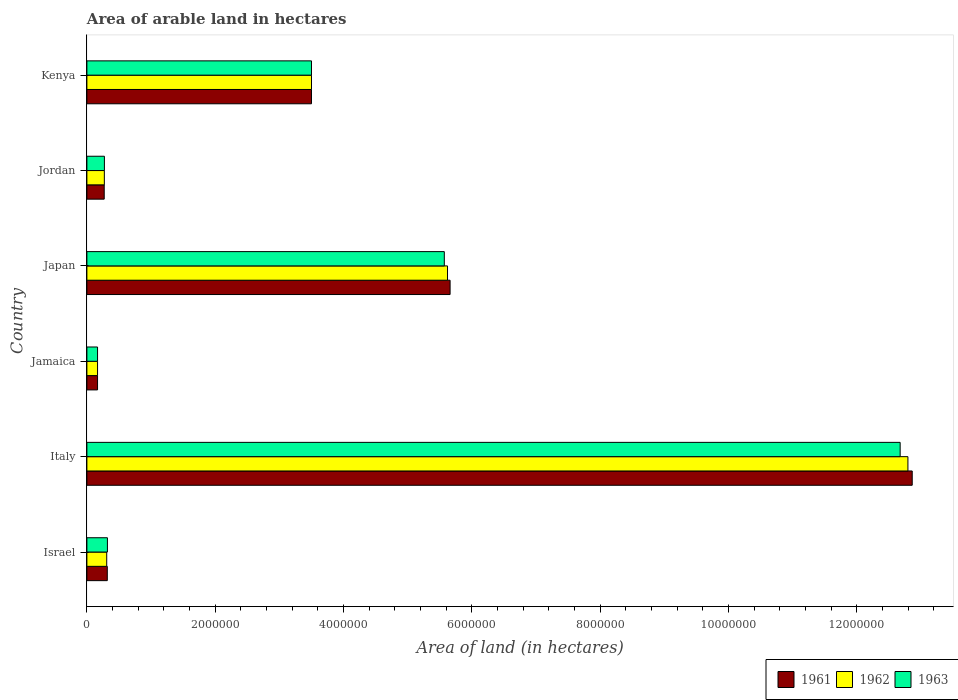How many groups of bars are there?
Make the answer very short. 6. What is the label of the 1st group of bars from the top?
Give a very brief answer. Kenya. In how many cases, is the number of bars for a given country not equal to the number of legend labels?
Keep it short and to the point. 0. What is the total arable land in 1961 in Japan?
Offer a terse response. 5.66e+06. Across all countries, what is the maximum total arable land in 1963?
Keep it short and to the point. 1.27e+07. Across all countries, what is the minimum total arable land in 1961?
Ensure brevity in your answer.  1.66e+05. In which country was the total arable land in 1963 minimum?
Your answer should be very brief. Jamaica. What is the total total arable land in 1963 in the graph?
Your response must be concise. 2.25e+07. What is the difference between the total arable land in 1963 in Israel and that in Italy?
Provide a succinct answer. -1.24e+07. What is the difference between the total arable land in 1962 in Israel and the total arable land in 1963 in Jamaica?
Provide a succinct answer. 1.43e+05. What is the average total arable land in 1963 per country?
Ensure brevity in your answer.  3.75e+06. In how many countries, is the total arable land in 1963 greater than 8000000 hectares?
Provide a succinct answer. 1. What is the ratio of the total arable land in 1961 in Israel to that in Jordan?
Your answer should be compact. 1.18. What is the difference between the highest and the second highest total arable land in 1961?
Provide a short and direct response. 7.20e+06. What is the difference between the highest and the lowest total arable land in 1963?
Provide a succinct answer. 1.25e+07. In how many countries, is the total arable land in 1962 greater than the average total arable land in 1962 taken over all countries?
Your answer should be compact. 2. Is the sum of the total arable land in 1963 in Italy and Jordan greater than the maximum total arable land in 1961 across all countries?
Offer a very short reply. Yes. How many bars are there?
Your response must be concise. 18. Are all the bars in the graph horizontal?
Your response must be concise. Yes. How many countries are there in the graph?
Your answer should be very brief. 6. Does the graph contain any zero values?
Offer a very short reply. No. How many legend labels are there?
Provide a succinct answer. 3. What is the title of the graph?
Ensure brevity in your answer.  Area of arable land in hectares. Does "1981" appear as one of the legend labels in the graph?
Your response must be concise. No. What is the label or title of the X-axis?
Offer a terse response. Area of land (in hectares). What is the label or title of the Y-axis?
Make the answer very short. Country. What is the Area of land (in hectares) of 1961 in Israel?
Provide a succinct answer. 3.18e+05. What is the Area of land (in hectares) of 1962 in Israel?
Your answer should be very brief. 3.09e+05. What is the Area of land (in hectares) of 1963 in Israel?
Give a very brief answer. 3.20e+05. What is the Area of land (in hectares) of 1961 in Italy?
Your answer should be very brief. 1.29e+07. What is the Area of land (in hectares) in 1962 in Italy?
Your answer should be very brief. 1.28e+07. What is the Area of land (in hectares) of 1963 in Italy?
Provide a short and direct response. 1.27e+07. What is the Area of land (in hectares) in 1961 in Jamaica?
Ensure brevity in your answer.  1.66e+05. What is the Area of land (in hectares) in 1962 in Jamaica?
Offer a very short reply. 1.66e+05. What is the Area of land (in hectares) in 1963 in Jamaica?
Keep it short and to the point. 1.66e+05. What is the Area of land (in hectares) of 1961 in Japan?
Keep it short and to the point. 5.66e+06. What is the Area of land (in hectares) in 1962 in Japan?
Your response must be concise. 5.62e+06. What is the Area of land (in hectares) of 1963 in Japan?
Offer a terse response. 5.57e+06. What is the Area of land (in hectares) in 1961 in Jordan?
Give a very brief answer. 2.70e+05. What is the Area of land (in hectares) in 1962 in Jordan?
Your answer should be compact. 2.72e+05. What is the Area of land (in hectares) in 1963 in Jordan?
Keep it short and to the point. 2.73e+05. What is the Area of land (in hectares) of 1961 in Kenya?
Keep it short and to the point. 3.50e+06. What is the Area of land (in hectares) of 1962 in Kenya?
Ensure brevity in your answer.  3.50e+06. What is the Area of land (in hectares) in 1963 in Kenya?
Provide a short and direct response. 3.50e+06. Across all countries, what is the maximum Area of land (in hectares) of 1961?
Your answer should be compact. 1.29e+07. Across all countries, what is the maximum Area of land (in hectares) in 1962?
Give a very brief answer. 1.28e+07. Across all countries, what is the maximum Area of land (in hectares) of 1963?
Give a very brief answer. 1.27e+07. Across all countries, what is the minimum Area of land (in hectares) in 1961?
Ensure brevity in your answer.  1.66e+05. Across all countries, what is the minimum Area of land (in hectares) in 1962?
Give a very brief answer. 1.66e+05. Across all countries, what is the minimum Area of land (in hectares) in 1963?
Your response must be concise. 1.66e+05. What is the total Area of land (in hectares) in 1961 in the graph?
Provide a succinct answer. 2.28e+07. What is the total Area of land (in hectares) in 1962 in the graph?
Provide a short and direct response. 2.27e+07. What is the total Area of land (in hectares) of 1963 in the graph?
Your answer should be very brief. 2.25e+07. What is the difference between the Area of land (in hectares) of 1961 in Israel and that in Italy?
Make the answer very short. -1.25e+07. What is the difference between the Area of land (in hectares) of 1962 in Israel and that in Italy?
Your answer should be compact. -1.25e+07. What is the difference between the Area of land (in hectares) in 1963 in Israel and that in Italy?
Provide a short and direct response. -1.24e+07. What is the difference between the Area of land (in hectares) in 1961 in Israel and that in Jamaica?
Keep it short and to the point. 1.52e+05. What is the difference between the Area of land (in hectares) of 1962 in Israel and that in Jamaica?
Make the answer very short. 1.43e+05. What is the difference between the Area of land (in hectares) of 1963 in Israel and that in Jamaica?
Provide a succinct answer. 1.54e+05. What is the difference between the Area of land (in hectares) of 1961 in Israel and that in Japan?
Keep it short and to the point. -5.34e+06. What is the difference between the Area of land (in hectares) in 1962 in Israel and that in Japan?
Keep it short and to the point. -5.31e+06. What is the difference between the Area of land (in hectares) of 1963 in Israel and that in Japan?
Give a very brief answer. -5.25e+06. What is the difference between the Area of land (in hectares) in 1961 in Israel and that in Jordan?
Your answer should be compact. 4.80e+04. What is the difference between the Area of land (in hectares) in 1962 in Israel and that in Jordan?
Your answer should be compact. 3.70e+04. What is the difference between the Area of land (in hectares) in 1963 in Israel and that in Jordan?
Your answer should be compact. 4.70e+04. What is the difference between the Area of land (in hectares) of 1961 in Israel and that in Kenya?
Provide a succinct answer. -3.18e+06. What is the difference between the Area of land (in hectares) in 1962 in Israel and that in Kenya?
Make the answer very short. -3.19e+06. What is the difference between the Area of land (in hectares) of 1963 in Israel and that in Kenya?
Make the answer very short. -3.18e+06. What is the difference between the Area of land (in hectares) in 1961 in Italy and that in Jamaica?
Your response must be concise. 1.27e+07. What is the difference between the Area of land (in hectares) in 1962 in Italy and that in Jamaica?
Offer a very short reply. 1.26e+07. What is the difference between the Area of land (in hectares) in 1963 in Italy and that in Jamaica?
Offer a very short reply. 1.25e+07. What is the difference between the Area of land (in hectares) of 1961 in Italy and that in Japan?
Keep it short and to the point. 7.20e+06. What is the difference between the Area of land (in hectares) of 1962 in Italy and that in Japan?
Your response must be concise. 7.18e+06. What is the difference between the Area of land (in hectares) in 1963 in Italy and that in Japan?
Your response must be concise. 7.10e+06. What is the difference between the Area of land (in hectares) of 1961 in Italy and that in Jordan?
Provide a succinct answer. 1.26e+07. What is the difference between the Area of land (in hectares) in 1962 in Italy and that in Jordan?
Offer a terse response. 1.25e+07. What is the difference between the Area of land (in hectares) of 1963 in Italy and that in Jordan?
Give a very brief answer. 1.24e+07. What is the difference between the Area of land (in hectares) in 1961 in Italy and that in Kenya?
Your answer should be very brief. 9.36e+06. What is the difference between the Area of land (in hectares) in 1962 in Italy and that in Kenya?
Provide a short and direct response. 9.30e+06. What is the difference between the Area of land (in hectares) of 1963 in Italy and that in Kenya?
Make the answer very short. 9.17e+06. What is the difference between the Area of land (in hectares) in 1961 in Jamaica and that in Japan?
Offer a very short reply. -5.49e+06. What is the difference between the Area of land (in hectares) of 1962 in Jamaica and that in Japan?
Your response must be concise. -5.45e+06. What is the difference between the Area of land (in hectares) in 1963 in Jamaica and that in Japan?
Your answer should be compact. -5.40e+06. What is the difference between the Area of land (in hectares) in 1961 in Jamaica and that in Jordan?
Your answer should be very brief. -1.04e+05. What is the difference between the Area of land (in hectares) of 1962 in Jamaica and that in Jordan?
Give a very brief answer. -1.06e+05. What is the difference between the Area of land (in hectares) in 1963 in Jamaica and that in Jordan?
Provide a succinct answer. -1.07e+05. What is the difference between the Area of land (in hectares) in 1961 in Jamaica and that in Kenya?
Offer a terse response. -3.33e+06. What is the difference between the Area of land (in hectares) of 1962 in Jamaica and that in Kenya?
Your response must be concise. -3.33e+06. What is the difference between the Area of land (in hectares) in 1963 in Jamaica and that in Kenya?
Provide a short and direct response. -3.33e+06. What is the difference between the Area of land (in hectares) in 1961 in Japan and that in Jordan?
Keep it short and to the point. 5.39e+06. What is the difference between the Area of land (in hectares) of 1962 in Japan and that in Jordan?
Provide a succinct answer. 5.35e+06. What is the difference between the Area of land (in hectares) in 1963 in Japan and that in Jordan?
Provide a short and direct response. 5.30e+06. What is the difference between the Area of land (in hectares) of 1961 in Japan and that in Kenya?
Make the answer very short. 2.16e+06. What is the difference between the Area of land (in hectares) in 1962 in Japan and that in Kenya?
Ensure brevity in your answer.  2.12e+06. What is the difference between the Area of land (in hectares) of 1963 in Japan and that in Kenya?
Keep it short and to the point. 2.07e+06. What is the difference between the Area of land (in hectares) of 1961 in Jordan and that in Kenya?
Make the answer very short. -3.23e+06. What is the difference between the Area of land (in hectares) of 1962 in Jordan and that in Kenya?
Offer a very short reply. -3.23e+06. What is the difference between the Area of land (in hectares) of 1963 in Jordan and that in Kenya?
Keep it short and to the point. -3.23e+06. What is the difference between the Area of land (in hectares) of 1961 in Israel and the Area of land (in hectares) of 1962 in Italy?
Offer a very short reply. -1.25e+07. What is the difference between the Area of land (in hectares) in 1961 in Israel and the Area of land (in hectares) in 1963 in Italy?
Your response must be concise. -1.24e+07. What is the difference between the Area of land (in hectares) of 1962 in Israel and the Area of land (in hectares) of 1963 in Italy?
Make the answer very short. -1.24e+07. What is the difference between the Area of land (in hectares) of 1961 in Israel and the Area of land (in hectares) of 1962 in Jamaica?
Your answer should be very brief. 1.52e+05. What is the difference between the Area of land (in hectares) in 1961 in Israel and the Area of land (in hectares) in 1963 in Jamaica?
Give a very brief answer. 1.52e+05. What is the difference between the Area of land (in hectares) of 1962 in Israel and the Area of land (in hectares) of 1963 in Jamaica?
Offer a terse response. 1.43e+05. What is the difference between the Area of land (in hectares) of 1961 in Israel and the Area of land (in hectares) of 1962 in Japan?
Offer a terse response. -5.30e+06. What is the difference between the Area of land (in hectares) in 1961 in Israel and the Area of land (in hectares) in 1963 in Japan?
Your answer should be compact. -5.25e+06. What is the difference between the Area of land (in hectares) of 1962 in Israel and the Area of land (in hectares) of 1963 in Japan?
Keep it short and to the point. -5.26e+06. What is the difference between the Area of land (in hectares) of 1961 in Israel and the Area of land (in hectares) of 1962 in Jordan?
Offer a very short reply. 4.60e+04. What is the difference between the Area of land (in hectares) in 1961 in Israel and the Area of land (in hectares) in 1963 in Jordan?
Your answer should be compact. 4.50e+04. What is the difference between the Area of land (in hectares) of 1962 in Israel and the Area of land (in hectares) of 1963 in Jordan?
Provide a succinct answer. 3.60e+04. What is the difference between the Area of land (in hectares) in 1961 in Israel and the Area of land (in hectares) in 1962 in Kenya?
Ensure brevity in your answer.  -3.18e+06. What is the difference between the Area of land (in hectares) of 1961 in Israel and the Area of land (in hectares) of 1963 in Kenya?
Your answer should be compact. -3.18e+06. What is the difference between the Area of land (in hectares) of 1962 in Israel and the Area of land (in hectares) of 1963 in Kenya?
Provide a short and direct response. -3.19e+06. What is the difference between the Area of land (in hectares) of 1961 in Italy and the Area of land (in hectares) of 1962 in Jamaica?
Keep it short and to the point. 1.27e+07. What is the difference between the Area of land (in hectares) in 1961 in Italy and the Area of land (in hectares) in 1963 in Jamaica?
Your answer should be very brief. 1.27e+07. What is the difference between the Area of land (in hectares) in 1962 in Italy and the Area of land (in hectares) in 1963 in Jamaica?
Make the answer very short. 1.26e+07. What is the difference between the Area of land (in hectares) in 1961 in Italy and the Area of land (in hectares) in 1962 in Japan?
Make the answer very short. 7.24e+06. What is the difference between the Area of land (in hectares) of 1961 in Italy and the Area of land (in hectares) of 1963 in Japan?
Give a very brief answer. 7.29e+06. What is the difference between the Area of land (in hectares) of 1962 in Italy and the Area of land (in hectares) of 1963 in Japan?
Keep it short and to the point. 7.22e+06. What is the difference between the Area of land (in hectares) in 1961 in Italy and the Area of land (in hectares) in 1962 in Jordan?
Keep it short and to the point. 1.26e+07. What is the difference between the Area of land (in hectares) in 1961 in Italy and the Area of land (in hectares) in 1963 in Jordan?
Provide a succinct answer. 1.26e+07. What is the difference between the Area of land (in hectares) of 1962 in Italy and the Area of land (in hectares) of 1963 in Jordan?
Provide a succinct answer. 1.25e+07. What is the difference between the Area of land (in hectares) in 1961 in Italy and the Area of land (in hectares) in 1962 in Kenya?
Your response must be concise. 9.36e+06. What is the difference between the Area of land (in hectares) in 1961 in Italy and the Area of land (in hectares) in 1963 in Kenya?
Provide a short and direct response. 9.36e+06. What is the difference between the Area of land (in hectares) of 1962 in Italy and the Area of land (in hectares) of 1963 in Kenya?
Ensure brevity in your answer.  9.30e+06. What is the difference between the Area of land (in hectares) in 1961 in Jamaica and the Area of land (in hectares) in 1962 in Japan?
Your answer should be compact. -5.45e+06. What is the difference between the Area of land (in hectares) of 1961 in Jamaica and the Area of land (in hectares) of 1963 in Japan?
Offer a very short reply. -5.40e+06. What is the difference between the Area of land (in hectares) in 1962 in Jamaica and the Area of land (in hectares) in 1963 in Japan?
Make the answer very short. -5.40e+06. What is the difference between the Area of land (in hectares) in 1961 in Jamaica and the Area of land (in hectares) in 1962 in Jordan?
Ensure brevity in your answer.  -1.06e+05. What is the difference between the Area of land (in hectares) in 1961 in Jamaica and the Area of land (in hectares) in 1963 in Jordan?
Your answer should be very brief. -1.07e+05. What is the difference between the Area of land (in hectares) in 1962 in Jamaica and the Area of land (in hectares) in 1963 in Jordan?
Make the answer very short. -1.07e+05. What is the difference between the Area of land (in hectares) of 1961 in Jamaica and the Area of land (in hectares) of 1962 in Kenya?
Keep it short and to the point. -3.33e+06. What is the difference between the Area of land (in hectares) in 1961 in Jamaica and the Area of land (in hectares) in 1963 in Kenya?
Make the answer very short. -3.33e+06. What is the difference between the Area of land (in hectares) of 1962 in Jamaica and the Area of land (in hectares) of 1963 in Kenya?
Make the answer very short. -3.33e+06. What is the difference between the Area of land (in hectares) in 1961 in Japan and the Area of land (in hectares) in 1962 in Jordan?
Provide a short and direct response. 5.39e+06. What is the difference between the Area of land (in hectares) in 1961 in Japan and the Area of land (in hectares) in 1963 in Jordan?
Your response must be concise. 5.39e+06. What is the difference between the Area of land (in hectares) in 1962 in Japan and the Area of land (in hectares) in 1963 in Jordan?
Make the answer very short. 5.35e+06. What is the difference between the Area of land (in hectares) in 1961 in Japan and the Area of land (in hectares) in 1962 in Kenya?
Your answer should be very brief. 2.16e+06. What is the difference between the Area of land (in hectares) of 1961 in Japan and the Area of land (in hectares) of 1963 in Kenya?
Your answer should be compact. 2.16e+06. What is the difference between the Area of land (in hectares) in 1962 in Japan and the Area of land (in hectares) in 1963 in Kenya?
Offer a terse response. 2.12e+06. What is the difference between the Area of land (in hectares) in 1961 in Jordan and the Area of land (in hectares) in 1962 in Kenya?
Offer a very short reply. -3.23e+06. What is the difference between the Area of land (in hectares) of 1961 in Jordan and the Area of land (in hectares) of 1963 in Kenya?
Your answer should be very brief. -3.23e+06. What is the difference between the Area of land (in hectares) of 1962 in Jordan and the Area of land (in hectares) of 1963 in Kenya?
Ensure brevity in your answer.  -3.23e+06. What is the average Area of land (in hectares) of 1961 per country?
Provide a short and direct response. 3.80e+06. What is the average Area of land (in hectares) of 1962 per country?
Provide a succinct answer. 3.78e+06. What is the average Area of land (in hectares) in 1963 per country?
Your response must be concise. 3.75e+06. What is the difference between the Area of land (in hectares) of 1961 and Area of land (in hectares) of 1962 in Israel?
Ensure brevity in your answer.  9000. What is the difference between the Area of land (in hectares) in 1961 and Area of land (in hectares) in 1963 in Israel?
Make the answer very short. -2000. What is the difference between the Area of land (in hectares) in 1962 and Area of land (in hectares) in 1963 in Israel?
Keep it short and to the point. -1.10e+04. What is the difference between the Area of land (in hectares) of 1961 and Area of land (in hectares) of 1962 in Italy?
Make the answer very short. 6.70e+04. What is the difference between the Area of land (in hectares) in 1961 and Area of land (in hectares) in 1963 in Italy?
Provide a succinct answer. 1.88e+05. What is the difference between the Area of land (in hectares) in 1962 and Area of land (in hectares) in 1963 in Italy?
Ensure brevity in your answer.  1.21e+05. What is the difference between the Area of land (in hectares) of 1961 and Area of land (in hectares) of 1962 in Jamaica?
Your answer should be very brief. 0. What is the difference between the Area of land (in hectares) in 1961 and Area of land (in hectares) in 1963 in Jamaica?
Provide a succinct answer. 0. What is the difference between the Area of land (in hectares) in 1961 and Area of land (in hectares) in 1963 in Japan?
Keep it short and to the point. 9.00e+04. What is the difference between the Area of land (in hectares) in 1962 and Area of land (in hectares) in 1963 in Japan?
Provide a short and direct response. 5.00e+04. What is the difference between the Area of land (in hectares) in 1961 and Area of land (in hectares) in 1962 in Jordan?
Your response must be concise. -2000. What is the difference between the Area of land (in hectares) in 1961 and Area of land (in hectares) in 1963 in Jordan?
Your answer should be compact. -3000. What is the difference between the Area of land (in hectares) in 1962 and Area of land (in hectares) in 1963 in Jordan?
Ensure brevity in your answer.  -1000. What is the difference between the Area of land (in hectares) in 1961 and Area of land (in hectares) in 1963 in Kenya?
Offer a very short reply. 0. What is the difference between the Area of land (in hectares) of 1962 and Area of land (in hectares) of 1963 in Kenya?
Your response must be concise. 0. What is the ratio of the Area of land (in hectares) in 1961 in Israel to that in Italy?
Your answer should be compact. 0.02. What is the ratio of the Area of land (in hectares) of 1962 in Israel to that in Italy?
Your answer should be compact. 0.02. What is the ratio of the Area of land (in hectares) of 1963 in Israel to that in Italy?
Provide a short and direct response. 0.03. What is the ratio of the Area of land (in hectares) in 1961 in Israel to that in Jamaica?
Offer a terse response. 1.92. What is the ratio of the Area of land (in hectares) of 1962 in Israel to that in Jamaica?
Provide a short and direct response. 1.86. What is the ratio of the Area of land (in hectares) of 1963 in Israel to that in Jamaica?
Provide a succinct answer. 1.93. What is the ratio of the Area of land (in hectares) of 1961 in Israel to that in Japan?
Your response must be concise. 0.06. What is the ratio of the Area of land (in hectares) in 1962 in Israel to that in Japan?
Your answer should be compact. 0.06. What is the ratio of the Area of land (in hectares) of 1963 in Israel to that in Japan?
Your answer should be compact. 0.06. What is the ratio of the Area of land (in hectares) of 1961 in Israel to that in Jordan?
Provide a succinct answer. 1.18. What is the ratio of the Area of land (in hectares) in 1962 in Israel to that in Jordan?
Ensure brevity in your answer.  1.14. What is the ratio of the Area of land (in hectares) of 1963 in Israel to that in Jordan?
Make the answer very short. 1.17. What is the ratio of the Area of land (in hectares) of 1961 in Israel to that in Kenya?
Ensure brevity in your answer.  0.09. What is the ratio of the Area of land (in hectares) of 1962 in Israel to that in Kenya?
Offer a very short reply. 0.09. What is the ratio of the Area of land (in hectares) in 1963 in Israel to that in Kenya?
Your response must be concise. 0.09. What is the ratio of the Area of land (in hectares) in 1961 in Italy to that in Jamaica?
Your answer should be compact. 77.48. What is the ratio of the Area of land (in hectares) in 1962 in Italy to that in Jamaica?
Make the answer very short. 77.08. What is the ratio of the Area of land (in hectares) of 1963 in Italy to that in Jamaica?
Give a very brief answer. 76.35. What is the ratio of the Area of land (in hectares) of 1961 in Italy to that in Japan?
Your answer should be compact. 2.27. What is the ratio of the Area of land (in hectares) in 1962 in Italy to that in Japan?
Provide a succinct answer. 2.28. What is the ratio of the Area of land (in hectares) in 1963 in Italy to that in Japan?
Make the answer very short. 2.28. What is the ratio of the Area of land (in hectares) of 1961 in Italy to that in Jordan?
Provide a short and direct response. 47.64. What is the ratio of the Area of land (in hectares) in 1962 in Italy to that in Jordan?
Keep it short and to the point. 47.04. What is the ratio of the Area of land (in hectares) of 1963 in Italy to that in Jordan?
Offer a very short reply. 46.42. What is the ratio of the Area of land (in hectares) in 1961 in Italy to that in Kenya?
Your response must be concise. 3.67. What is the ratio of the Area of land (in hectares) of 1962 in Italy to that in Kenya?
Offer a terse response. 3.66. What is the ratio of the Area of land (in hectares) of 1963 in Italy to that in Kenya?
Provide a short and direct response. 3.62. What is the ratio of the Area of land (in hectares) in 1961 in Jamaica to that in Japan?
Give a very brief answer. 0.03. What is the ratio of the Area of land (in hectares) in 1962 in Jamaica to that in Japan?
Give a very brief answer. 0.03. What is the ratio of the Area of land (in hectares) of 1963 in Jamaica to that in Japan?
Provide a short and direct response. 0.03. What is the ratio of the Area of land (in hectares) in 1961 in Jamaica to that in Jordan?
Your answer should be very brief. 0.61. What is the ratio of the Area of land (in hectares) in 1962 in Jamaica to that in Jordan?
Provide a short and direct response. 0.61. What is the ratio of the Area of land (in hectares) of 1963 in Jamaica to that in Jordan?
Ensure brevity in your answer.  0.61. What is the ratio of the Area of land (in hectares) of 1961 in Jamaica to that in Kenya?
Make the answer very short. 0.05. What is the ratio of the Area of land (in hectares) in 1962 in Jamaica to that in Kenya?
Keep it short and to the point. 0.05. What is the ratio of the Area of land (in hectares) in 1963 in Jamaica to that in Kenya?
Provide a succinct answer. 0.05. What is the ratio of the Area of land (in hectares) of 1961 in Japan to that in Jordan?
Keep it short and to the point. 20.96. What is the ratio of the Area of land (in hectares) of 1962 in Japan to that in Jordan?
Give a very brief answer. 20.66. What is the ratio of the Area of land (in hectares) in 1963 in Japan to that in Jordan?
Ensure brevity in your answer.  20.4. What is the ratio of the Area of land (in hectares) in 1961 in Japan to that in Kenya?
Provide a succinct answer. 1.62. What is the ratio of the Area of land (in hectares) of 1962 in Japan to that in Kenya?
Your response must be concise. 1.61. What is the ratio of the Area of land (in hectares) of 1963 in Japan to that in Kenya?
Offer a terse response. 1.59. What is the ratio of the Area of land (in hectares) in 1961 in Jordan to that in Kenya?
Provide a succinct answer. 0.08. What is the ratio of the Area of land (in hectares) of 1962 in Jordan to that in Kenya?
Give a very brief answer. 0.08. What is the ratio of the Area of land (in hectares) in 1963 in Jordan to that in Kenya?
Make the answer very short. 0.08. What is the difference between the highest and the second highest Area of land (in hectares) of 1961?
Your answer should be compact. 7.20e+06. What is the difference between the highest and the second highest Area of land (in hectares) in 1962?
Your response must be concise. 7.18e+06. What is the difference between the highest and the second highest Area of land (in hectares) in 1963?
Make the answer very short. 7.10e+06. What is the difference between the highest and the lowest Area of land (in hectares) in 1961?
Offer a very short reply. 1.27e+07. What is the difference between the highest and the lowest Area of land (in hectares) of 1962?
Keep it short and to the point. 1.26e+07. What is the difference between the highest and the lowest Area of land (in hectares) in 1963?
Make the answer very short. 1.25e+07. 